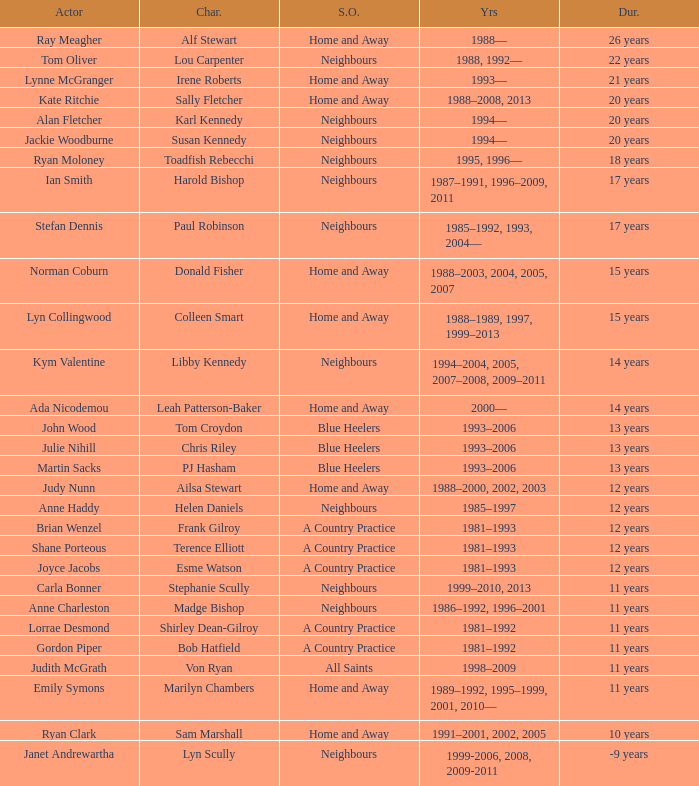Which years did Martin Sacks work on a soap opera? 1993–2006. 